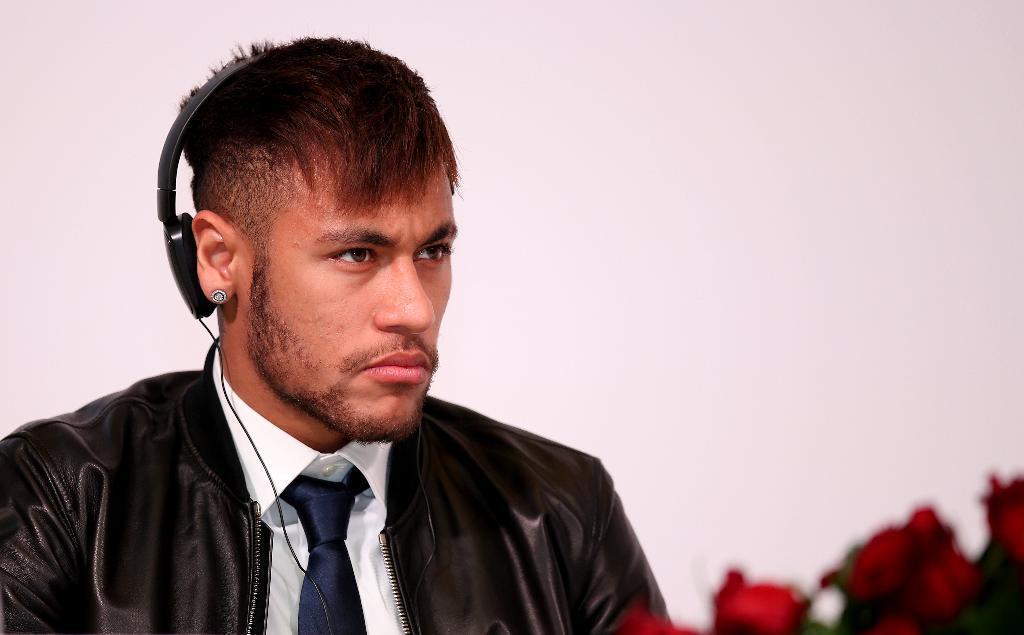In one or two sentences, can you explain what this image depicts? In this image, we can see a person on the white background. This person is wearing clothes and headset. There are flowers in the bottom right of the image. 